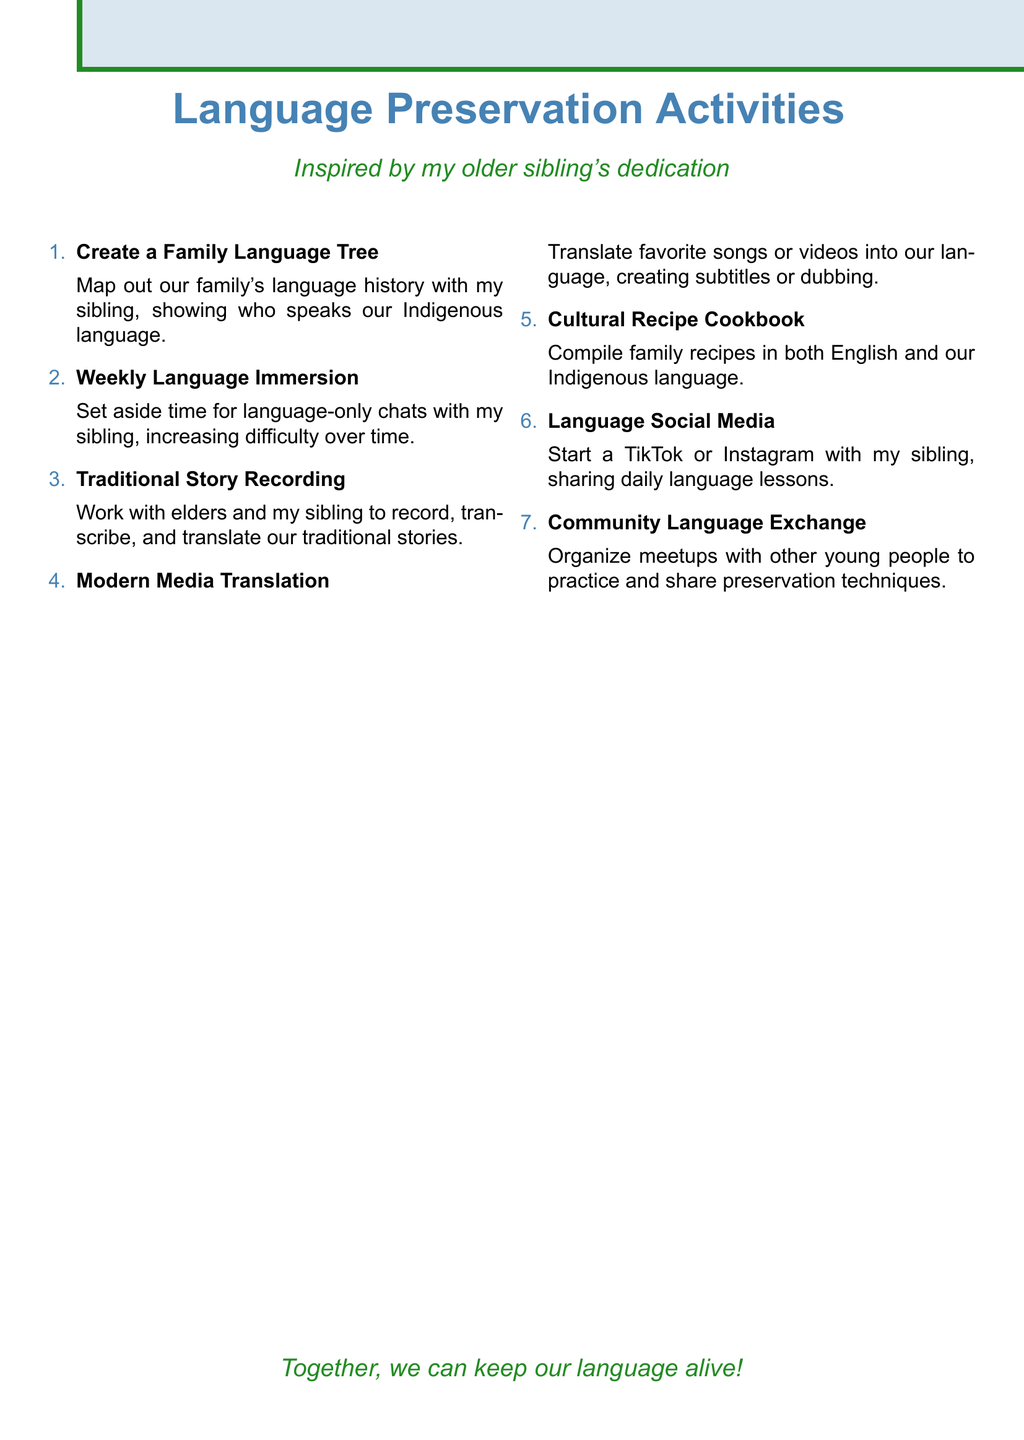What is the title of the first activity? The title of the first activity is presented at the top of the list of language preservation activities.
Answer: Create a Family Language Tree How many language preservation activities are listed? The document contains a numbered list of activities that can be counted.
Answer: Seven What activity involves elders? This activity specifically mentions collaboration with elders in its description.
Answer: Traditional Story Recording Project Which activity includes creating a social media account? The activity that suggests starting a social media account is noted in the document.
Answer: Language Preservation Social Media Account What is the focus of the "Weekly Language Immersion Sessions"? The focus is on language-only conversations with an increasing duration and complexity over time.
Answer: Language-only conversations Name an activity related to translating modern media. This activity is focused on translating popular forms of modern entertainment into the Indigenous language.
Answer: Modern Media Translation Challenge Which activity involves compiling recipes? This activity mentions compiling traditional family recipes and writing them in both English and the Indigenous language.
Answer: Cultural Recipe Cookbook How often should language immersion sessions take place? The description indicates a regular schedule for the language immersion sessions.
Answer: Weekly What is the main objective of the Community Language Exchange? The objective is to practice the language and share preservation techniques.
Answer: Practice and share preservation techniques 